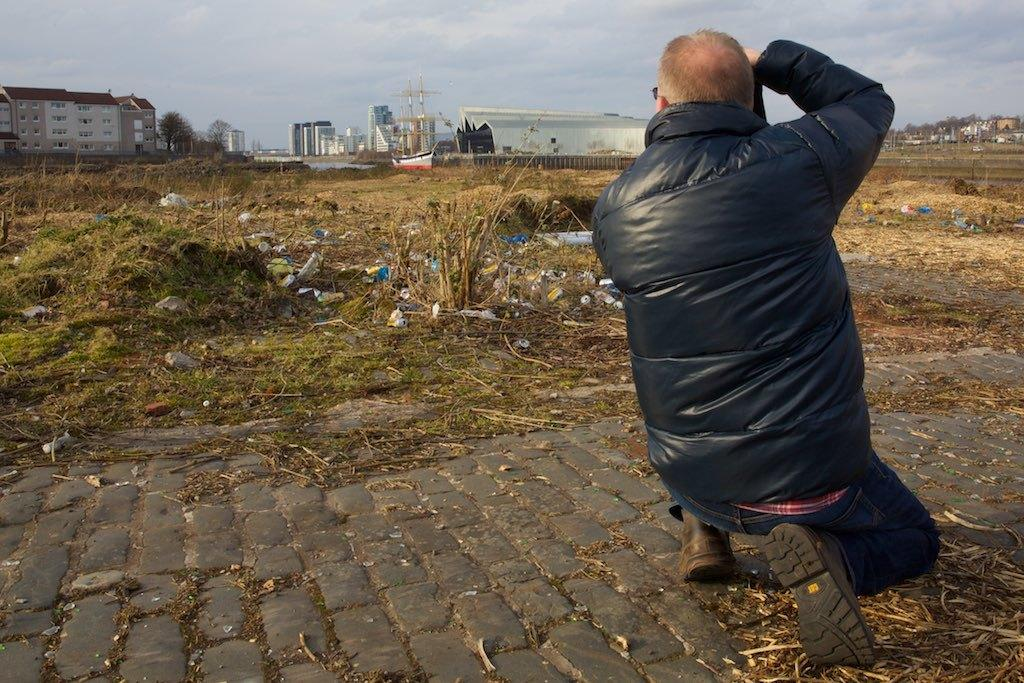Who is present in the image? There is a man in the image. What is the man wearing? The man is wearing clothes, shoes, and goggles. What type of surface can be seen in the image? There is a footpath in the image. What type of vegetation is present in the image? There is grass in the image. What type of structures can be seen in the image? There are buildings in the image. What part of the natural environment is visible in the image? The sky is visible in the image. What type of hook can be seen hanging from the man's goggles in the image? There is no hook present on the man's goggles in the image. What type of root is growing through the grass in the image? There is no root visible in the grass in the image. 